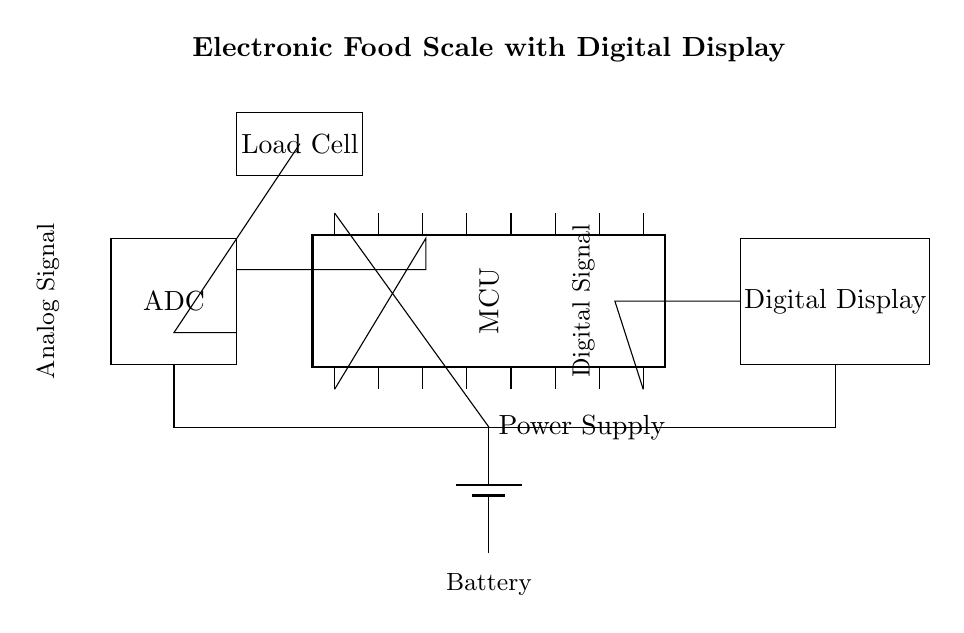What is the main component for weight measurement? The main component for weight measurement is the Load Cell, which converts the weight applied to it into an electrical signal.
Answer: Load Cell What type of signal does the ADC process? The ADC processes an Analog Signal, converting the continuous electrical signals from the Load Cell into a digital format that can be processed by the Microcontroller.
Answer: Analog Signal How many pins does the microcontroller have? The microcontroller has 16 pins, as indicated in the diagram.
Answer: 16 What is the purpose of the digital display? The purpose of the digital display is to show the measured weight in a readable format, providing users with immediate feedback on the scale reading.
Answer: Show weight What is the connection between the Load Cell and the ADC? The Load Cell is connected to the ADC through an analog signal line, which provides the ADC with the electrical signal corresponding to the weight sensed by the Load Cell.
Answer: Analog Signal Line Which component provides power to the circuit? The component that provides power to the circuit is the Battery, which supplies the necessary voltage for the operation of the Microcontroller and other components.
Answer: Battery 